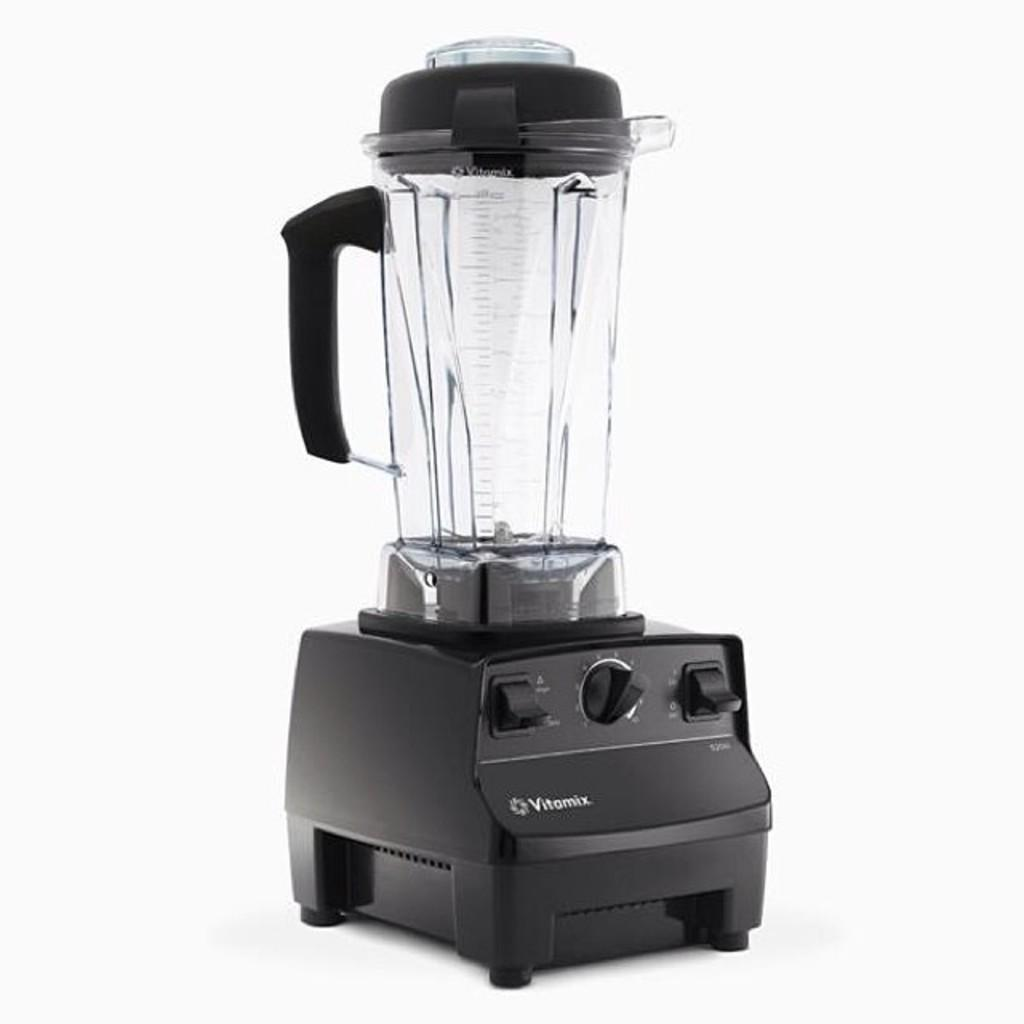<image>
Create a compact narrative representing the image presented. A blender made by the brand Vitamix sit on a white background. 